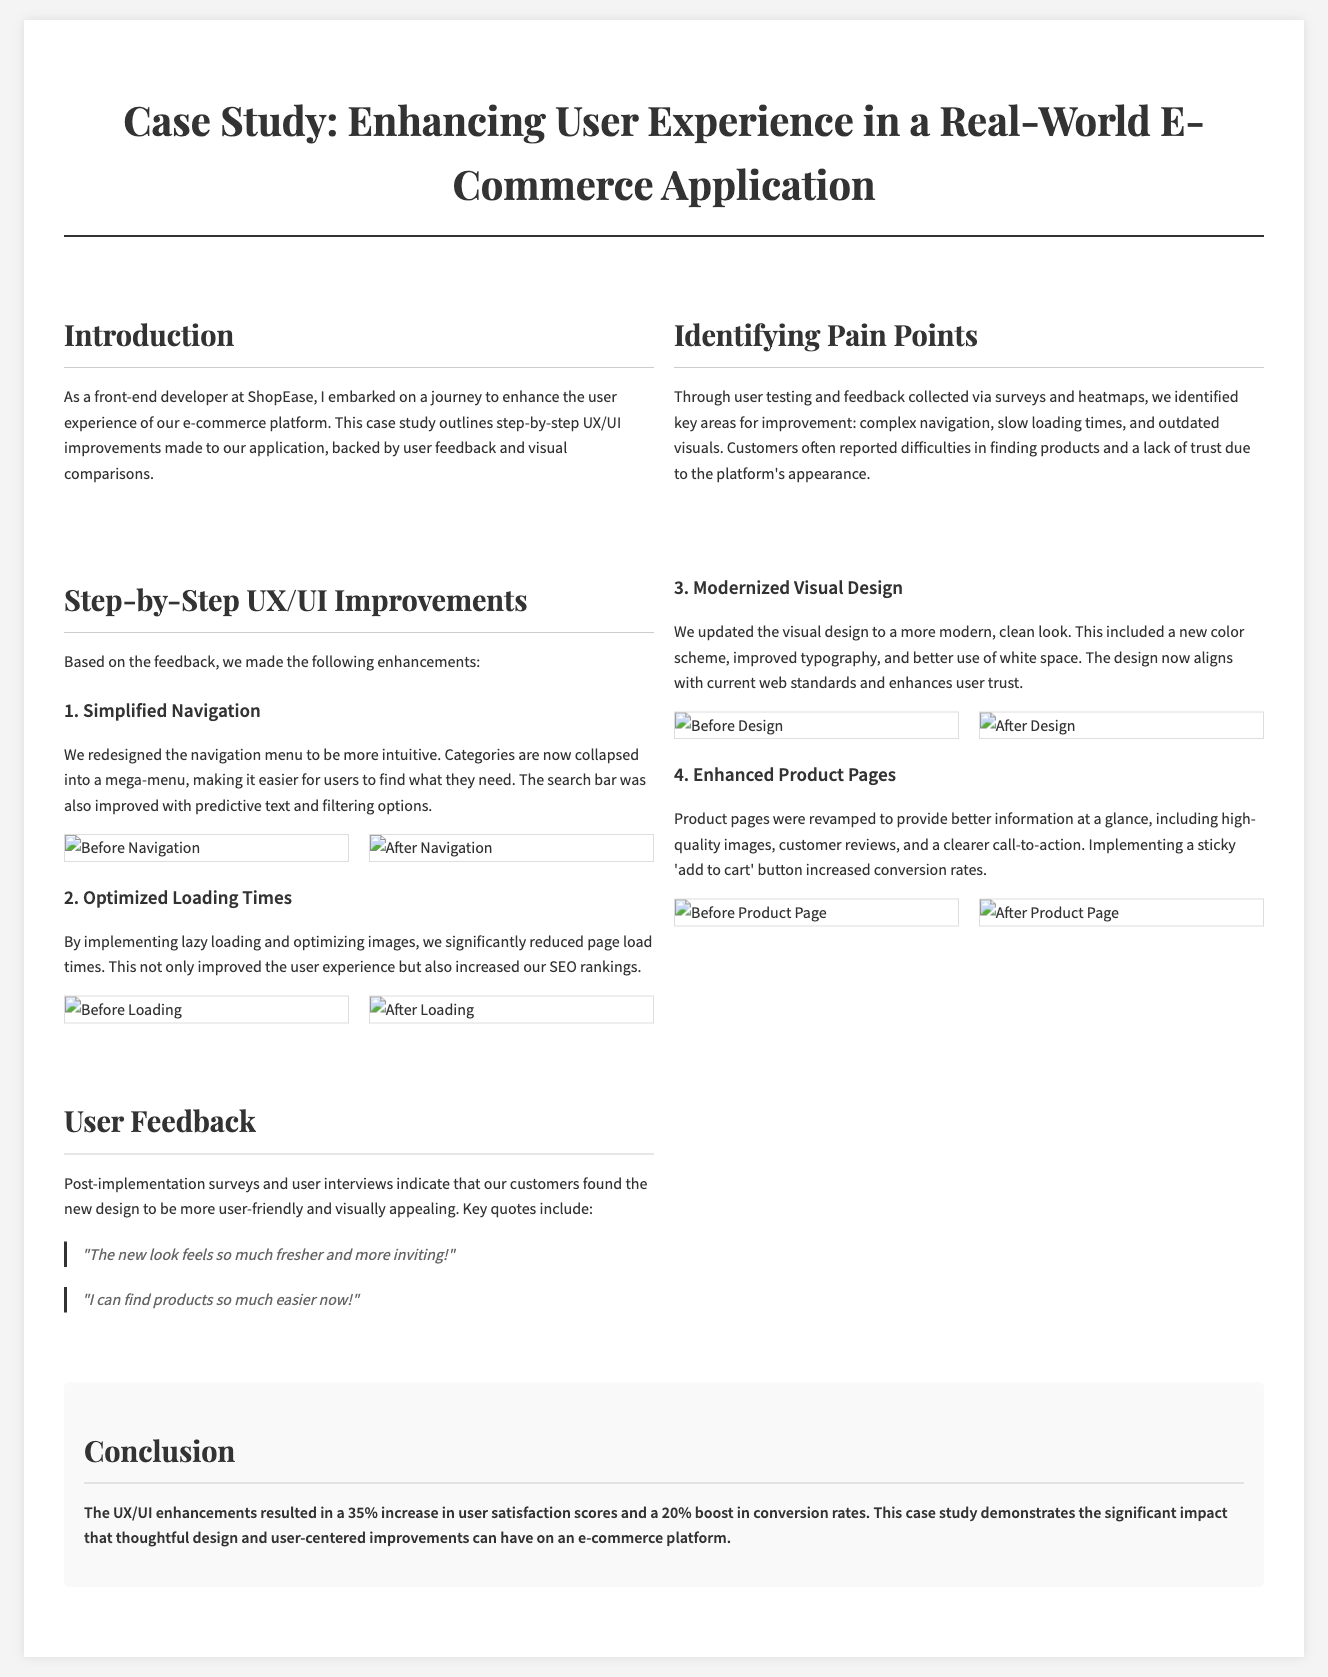What is the title of the case study? The title is found in the headline section of the document, which clearly states the name of the case study.
Answer: Case Study: Enhancing User Experience in a Real-World E-Commerce Application Which company is highlighted in the case study? The company ShopEase is mentioned in the introduction as the one undergoing the UX/UI enhancements.
Answer: ShopEase What percentage increase in user satisfaction scores was reported? The conclusion section provides specific results regarding user satisfaction outcomes after enhancements.
Answer: 35% Which improvement involved reworking product information? A specific enhancement in the document addresses the revamp of product pages for better information delivery.
Answer: Enhanced Product Pages What was the primary issue identified related to navigation? The section discussing pain points explicitly mentions navigation difficulties reported by users.
Answer: Complex navigation What feature was added to the search bar? The section detailing simplified navigation describes an improvement that enhances the search functionality.
Answer: Predictive text What color scheme aspect was updated in the visual design? The modernized visual design section specifically mentions a new color scheme as part of the enhancements.
Answer: New color scheme What specific loading performance strategy was implemented? The improvements section names lazy loading as a method introduced to improve performance.
Answer: Lazy loading 